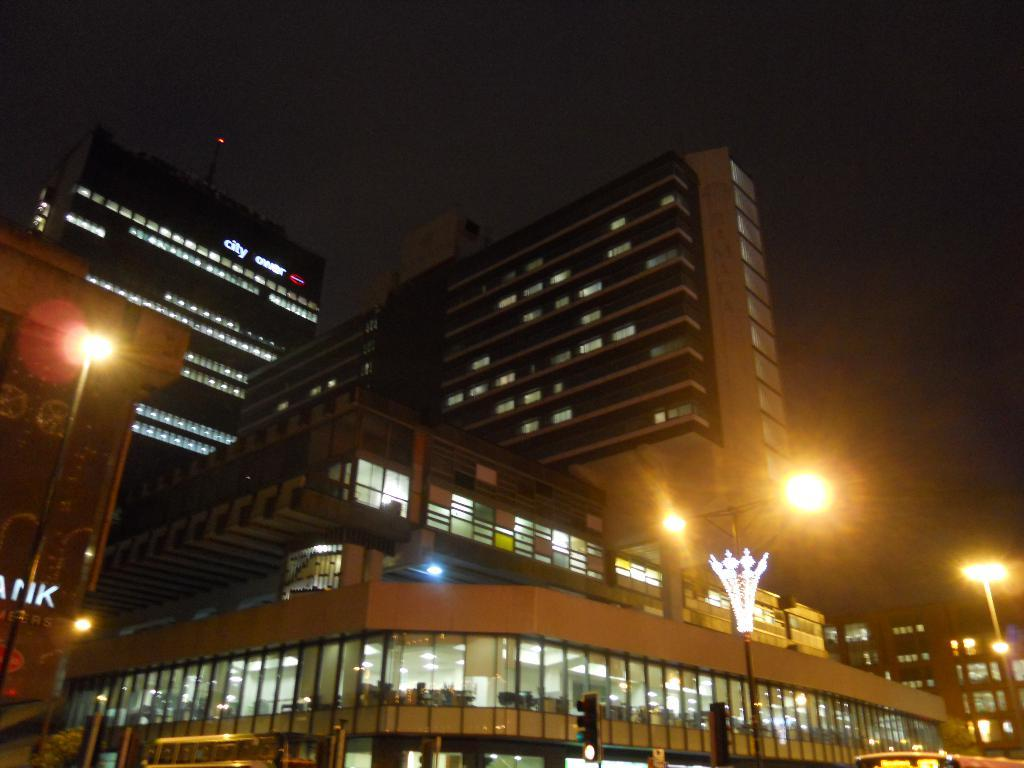What type of buildings are visible in the image? There are buildings with glass windows in the image. What can be seen attached to poles in the image? There are lights attached to poles in the image. What part of the natural environment is visible in the image? The sky is visible in the image. How would you describe the color of the background in the image? The background appears to be dark in color. How many cakes are being taxed in the image? There are no cakes or tax-related elements present in the image. What type of crow is perched on the building in the image? There is no crow present in the image; only buildings with glass windows, lights attached to poles, the sky, and a dark background are visible. 